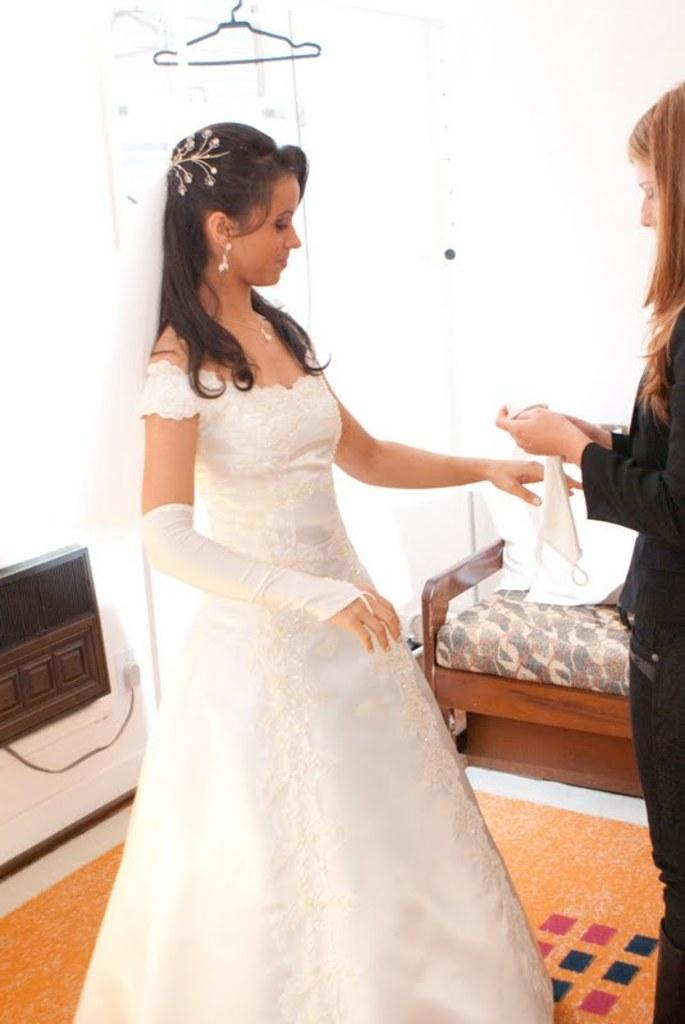How many people are in the image? There are two persons in the image. Can you describe one of the persons in the image? One of the persons is a woman. What is the woman wearing in the image? The woman is wearing a white color bridal dress. What can be seen in the background of the image? There is a bench and a floor mat on the floor in the background of the image. What type of cherry is the woman holding in the image? There is no cherry present in the image; the woman is wearing a bridal dress. How many cows are visible in the image? There are no cows present in the image. 